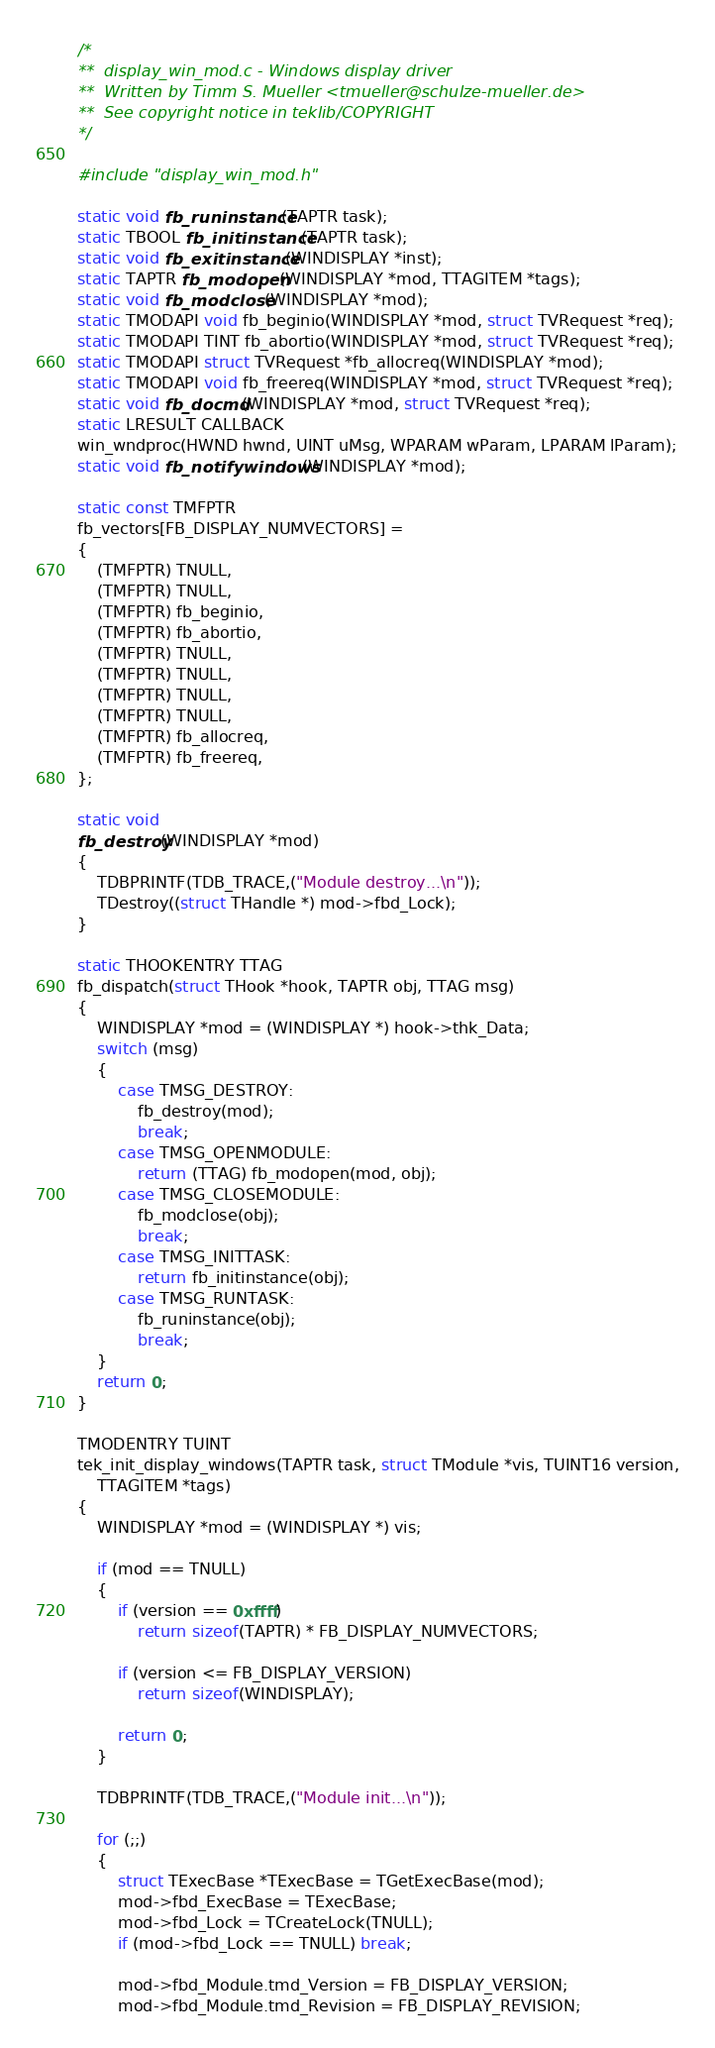<code> <loc_0><loc_0><loc_500><loc_500><_C_>
/*
**	display_win_mod.c - Windows display driver
**	Written by Timm S. Mueller <tmueller@schulze-mueller.de>
**	See copyright notice in teklib/COPYRIGHT
*/

#include "display_win_mod.h"

static void fb_runinstance(TAPTR task);
static TBOOL fb_initinstance(TAPTR task);
static void fb_exitinstance(WINDISPLAY *inst);
static TAPTR fb_modopen(WINDISPLAY *mod, TTAGITEM *tags);
static void fb_modclose(WINDISPLAY *mod);
static TMODAPI void fb_beginio(WINDISPLAY *mod, struct TVRequest *req);
static TMODAPI TINT fb_abortio(WINDISPLAY *mod, struct TVRequest *req);
static TMODAPI struct TVRequest *fb_allocreq(WINDISPLAY *mod);
static TMODAPI void fb_freereq(WINDISPLAY *mod, struct TVRequest *req);
static void fb_docmd(WINDISPLAY *mod, struct TVRequest *req);
static LRESULT CALLBACK
win_wndproc(HWND hwnd, UINT uMsg, WPARAM wParam, LPARAM lParam);
static void fb_notifywindows(WINDISPLAY *mod);

static const TMFPTR
fb_vectors[FB_DISPLAY_NUMVECTORS] =
{
	(TMFPTR) TNULL,
	(TMFPTR) TNULL,
	(TMFPTR) fb_beginio,
	(TMFPTR) fb_abortio,
	(TMFPTR) TNULL,
	(TMFPTR) TNULL,
	(TMFPTR) TNULL,
	(TMFPTR) TNULL,
	(TMFPTR) fb_allocreq,
	(TMFPTR) fb_freereq,
};

static void
fb_destroy(WINDISPLAY *mod)
{
	TDBPRINTF(TDB_TRACE,("Module destroy...\n"));
	TDestroy((struct THandle *) mod->fbd_Lock);
}

static THOOKENTRY TTAG
fb_dispatch(struct THook *hook, TAPTR obj, TTAG msg)
{
	WINDISPLAY *mod = (WINDISPLAY *) hook->thk_Data;
	switch (msg)
	{
		case TMSG_DESTROY:
			fb_destroy(mod);
			break;
		case TMSG_OPENMODULE:
			return (TTAG) fb_modopen(mod, obj);
		case TMSG_CLOSEMODULE:
			fb_modclose(obj);
			break;
		case TMSG_INITTASK:
			return fb_initinstance(obj);
		case TMSG_RUNTASK:
			fb_runinstance(obj);
			break;
	}
	return 0;
}

TMODENTRY TUINT
tek_init_display_windows(TAPTR task, struct TModule *vis, TUINT16 version,
	TTAGITEM *tags)
{
	WINDISPLAY *mod = (WINDISPLAY *) vis;

	if (mod == TNULL)
	{
		if (version == 0xffff)
			return sizeof(TAPTR) * FB_DISPLAY_NUMVECTORS;

		if (version <= FB_DISPLAY_VERSION)
			return sizeof(WINDISPLAY);

		return 0;
	}

	TDBPRINTF(TDB_TRACE,("Module init...\n"));

	for (;;)
	{
		struct TExecBase *TExecBase = TGetExecBase(mod);
		mod->fbd_ExecBase = TExecBase;
		mod->fbd_Lock = TCreateLock(TNULL);
		if (mod->fbd_Lock == TNULL) break;

		mod->fbd_Module.tmd_Version = FB_DISPLAY_VERSION;
		mod->fbd_Module.tmd_Revision = FB_DISPLAY_REVISION;</code> 